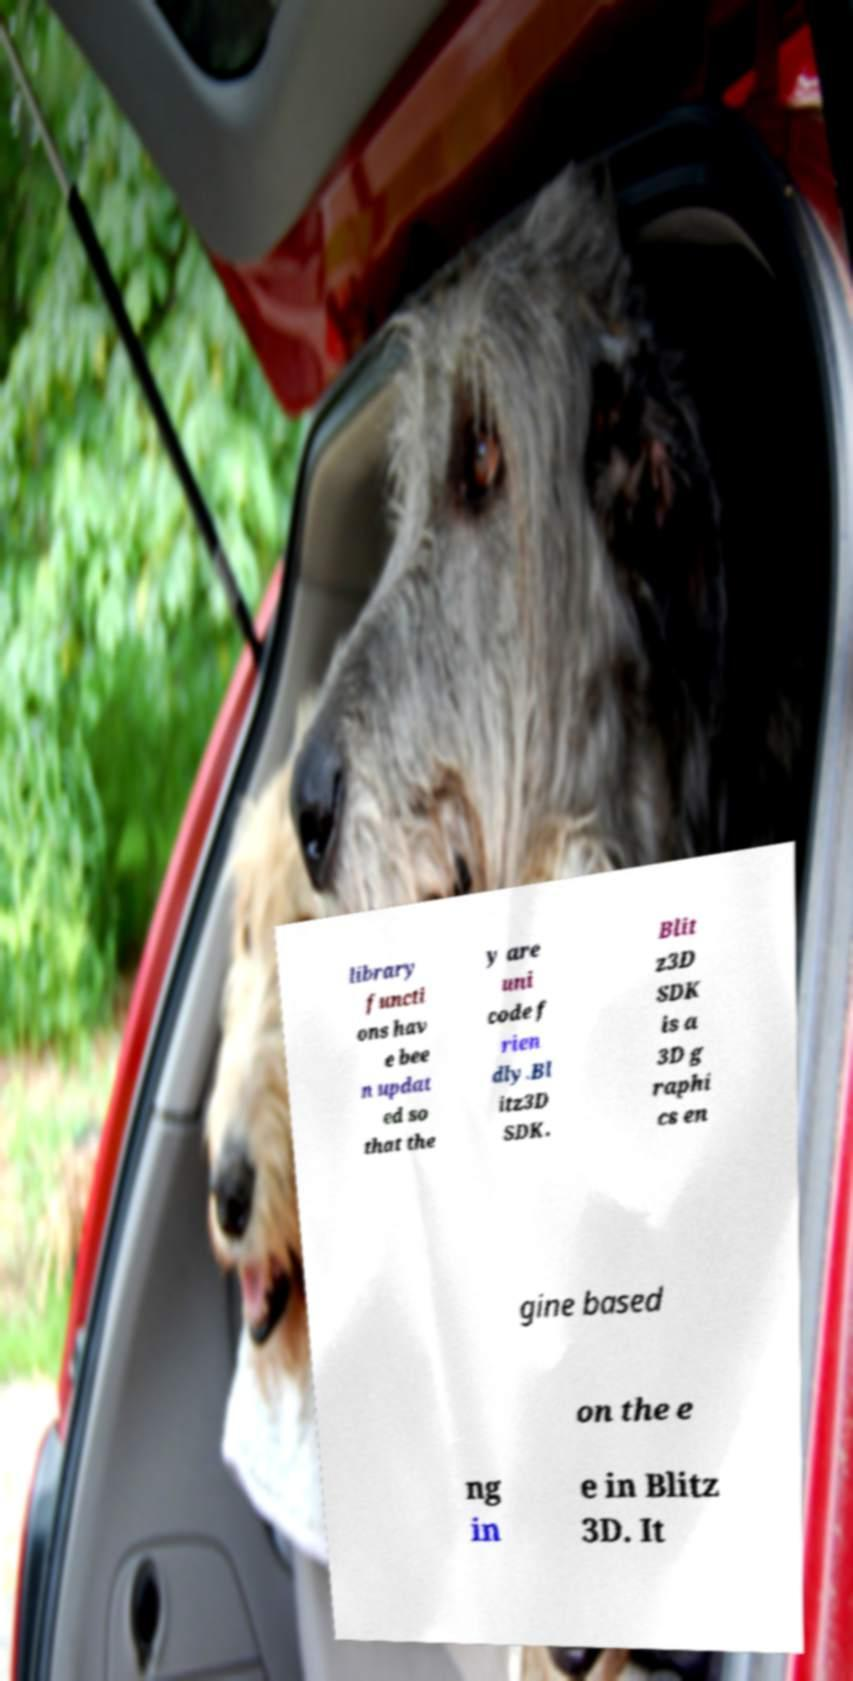Please read and relay the text visible in this image. What does it say? library functi ons hav e bee n updat ed so that the y are uni code f rien dly.Bl itz3D SDK. Blit z3D SDK is a 3D g raphi cs en gine based on the e ng in e in Blitz 3D. It 